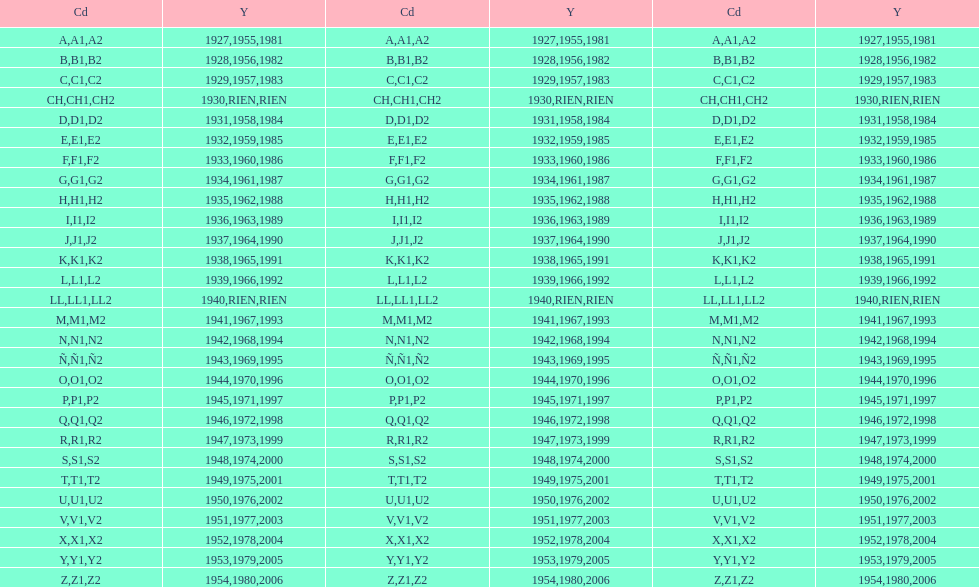List each code not associated to a year. CH1, CH2, LL1, LL2. 